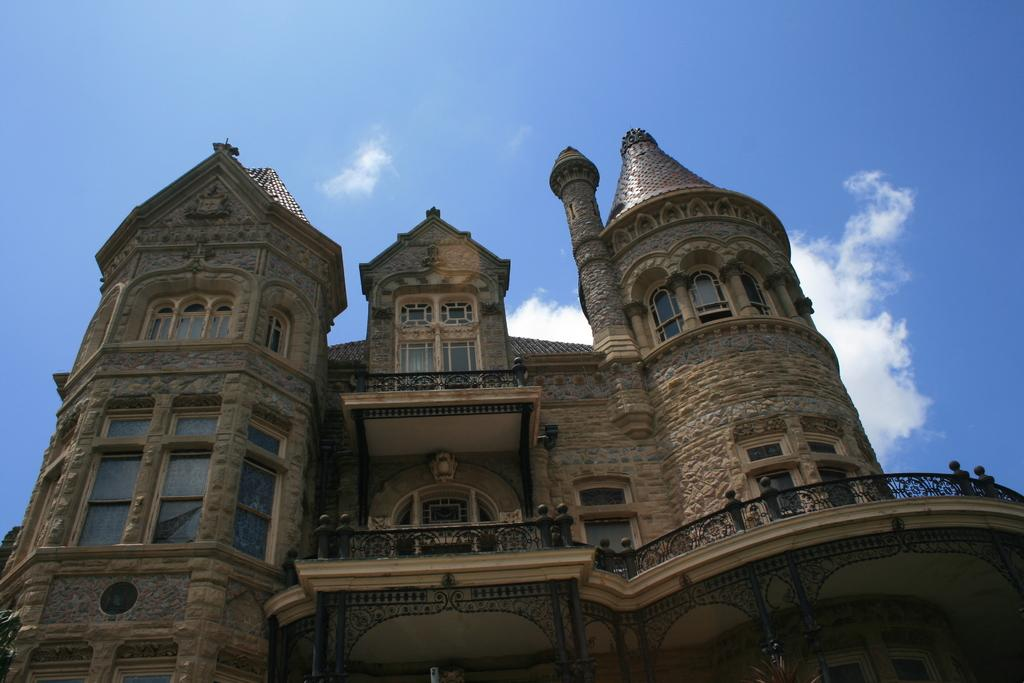What type of structure is in the image? There is a castle in the image. What features can be seen on the castle? The castle has windows and a balcony. What is visible at the top of the image? The sky is visible at the top of the image. What can be observed in the sky? There are clouds in the sky. Where is the cap placed in the image? There is no cap present in the image. What type of notebook is being used for learning in the image? There is no notebook or learning activity depicted in the image. 